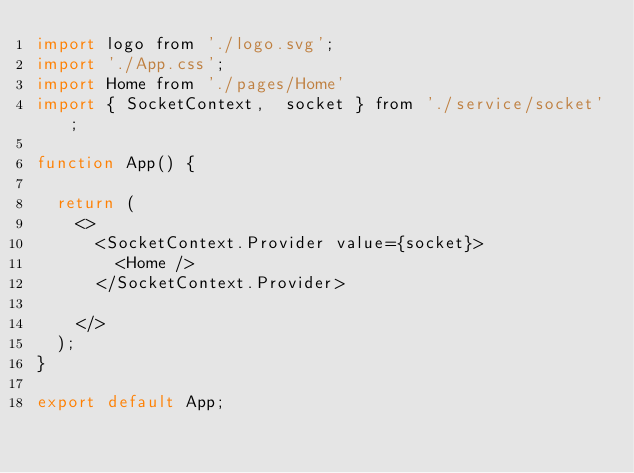Convert code to text. <code><loc_0><loc_0><loc_500><loc_500><_JavaScript_>import logo from './logo.svg';
import './App.css';
import Home from './pages/Home'
import { SocketContext,  socket } from './service/socket';

function App() {

  return (
    <>
      <SocketContext.Provider value={socket}>
        <Home />
      </SocketContext.Provider>

    </>
  );
}

export default App;
</code> 